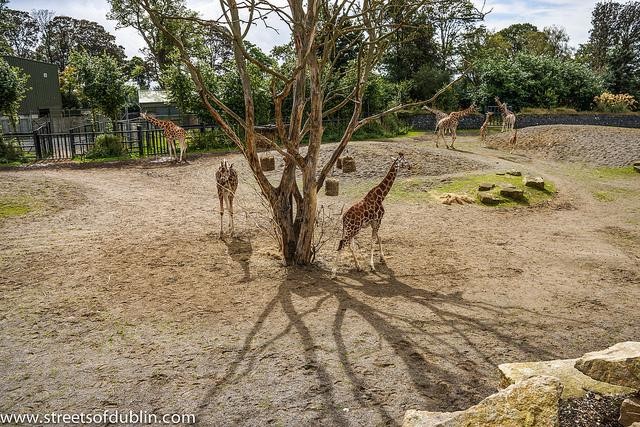What are the giraffes near? tree 